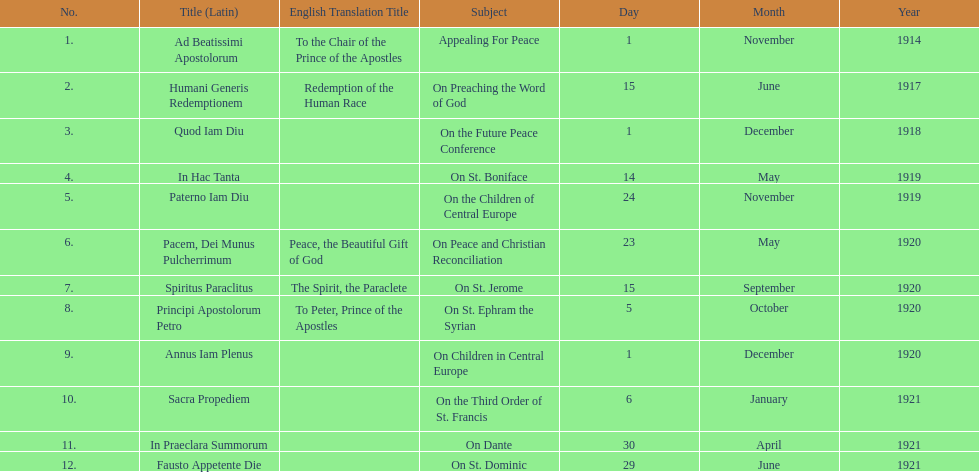How many titles did not list an english translation? 7. 